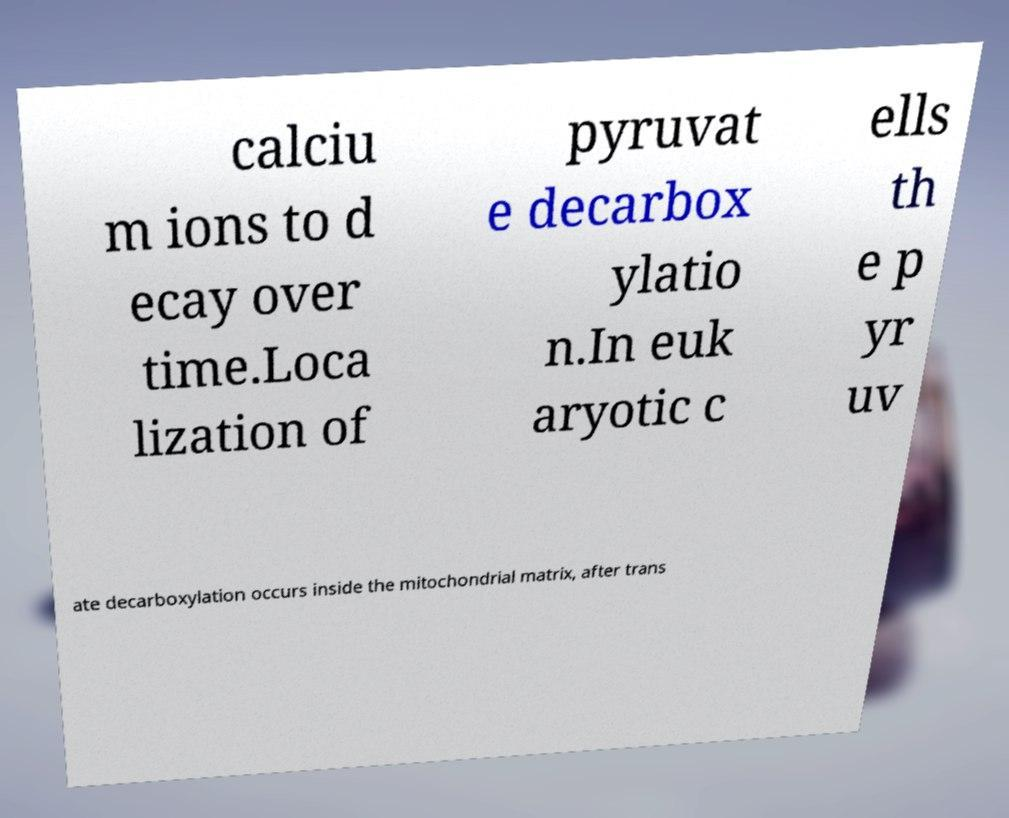Can you read and provide the text displayed in the image?This photo seems to have some interesting text. Can you extract and type it out for me? calciu m ions to d ecay over time.Loca lization of pyruvat e decarbox ylatio n.In euk aryotic c ells th e p yr uv ate decarboxylation occurs inside the mitochondrial matrix, after trans 